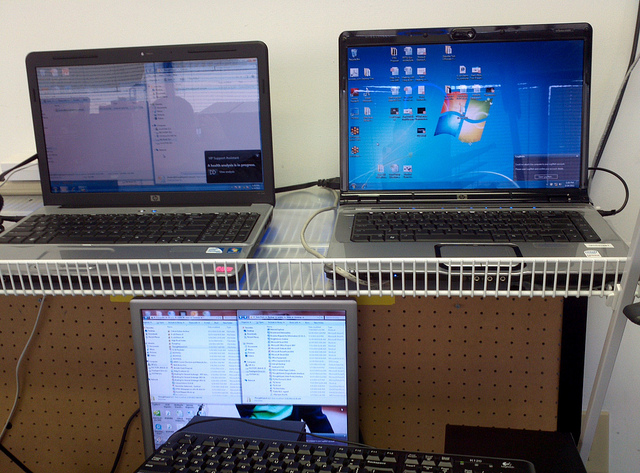How many screens do you see? 3 